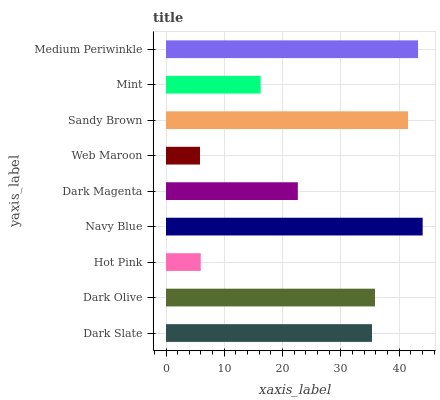Is Web Maroon the minimum?
Answer yes or no. Yes. Is Navy Blue the maximum?
Answer yes or no. Yes. Is Dark Olive the minimum?
Answer yes or no. No. Is Dark Olive the maximum?
Answer yes or no. No. Is Dark Olive greater than Dark Slate?
Answer yes or no. Yes. Is Dark Slate less than Dark Olive?
Answer yes or no. Yes. Is Dark Slate greater than Dark Olive?
Answer yes or no. No. Is Dark Olive less than Dark Slate?
Answer yes or no. No. Is Dark Slate the high median?
Answer yes or no. Yes. Is Dark Slate the low median?
Answer yes or no. Yes. Is Medium Periwinkle the high median?
Answer yes or no. No. Is Dark Olive the low median?
Answer yes or no. No. 